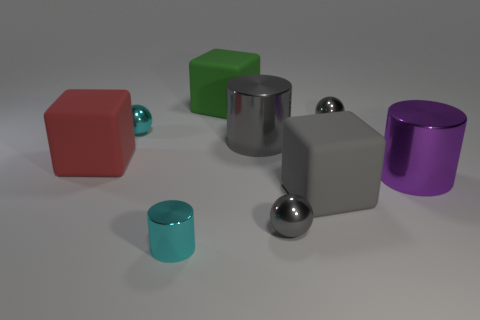Add 1 tiny cyan spheres. How many objects exist? 10 Subtract all purple balls. Subtract all yellow cylinders. How many balls are left? 3 Subtract all blocks. How many objects are left? 6 Add 7 small balls. How many small balls are left? 10 Add 4 small red metal spheres. How many small red metal spheres exist? 4 Subtract 0 green spheres. How many objects are left? 9 Subtract all large gray matte cubes. Subtract all cyan metallic cylinders. How many objects are left? 7 